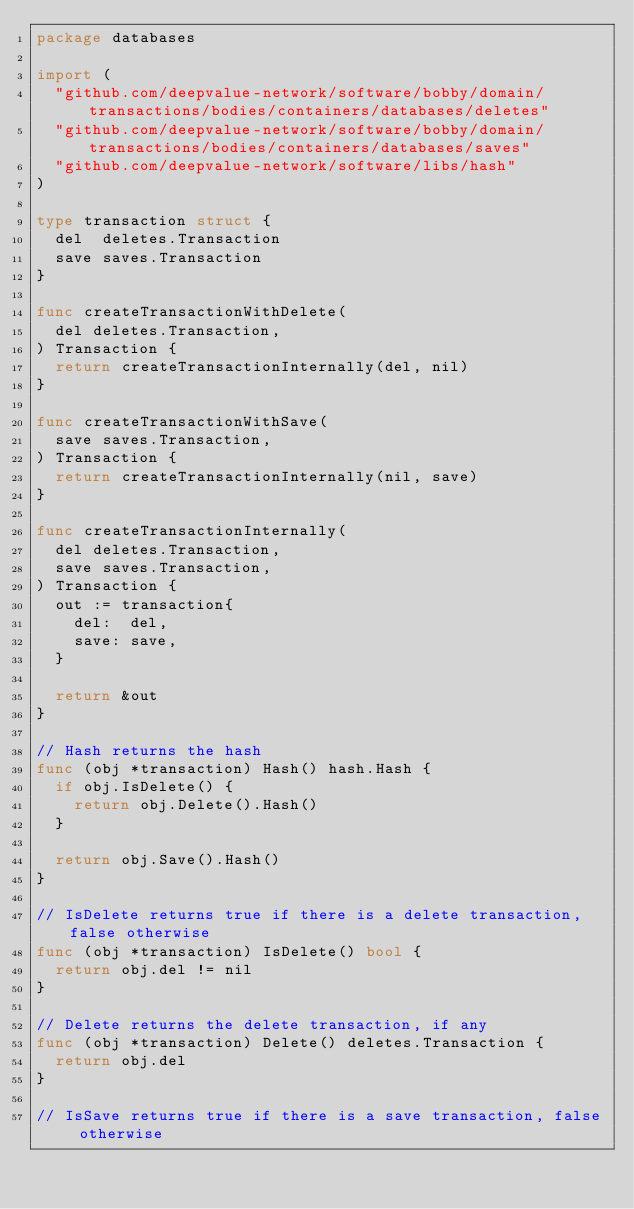<code> <loc_0><loc_0><loc_500><loc_500><_Go_>package databases

import (
	"github.com/deepvalue-network/software/bobby/domain/transactions/bodies/containers/databases/deletes"
	"github.com/deepvalue-network/software/bobby/domain/transactions/bodies/containers/databases/saves"
	"github.com/deepvalue-network/software/libs/hash"
)

type transaction struct {
	del  deletes.Transaction
	save saves.Transaction
}

func createTransactionWithDelete(
	del deletes.Transaction,
) Transaction {
	return createTransactionInternally(del, nil)
}

func createTransactionWithSave(
	save saves.Transaction,
) Transaction {
	return createTransactionInternally(nil, save)
}

func createTransactionInternally(
	del deletes.Transaction,
	save saves.Transaction,
) Transaction {
	out := transaction{
		del:  del,
		save: save,
	}

	return &out
}

// Hash returns the hash
func (obj *transaction) Hash() hash.Hash {
	if obj.IsDelete() {
		return obj.Delete().Hash()
	}

	return obj.Save().Hash()
}

// IsDelete returns true if there is a delete transaction, false otherwise
func (obj *transaction) IsDelete() bool {
	return obj.del != nil
}

// Delete returns the delete transaction, if any
func (obj *transaction) Delete() deletes.Transaction {
	return obj.del
}

// IsSave returns true if there is a save transaction, false otherwise</code> 